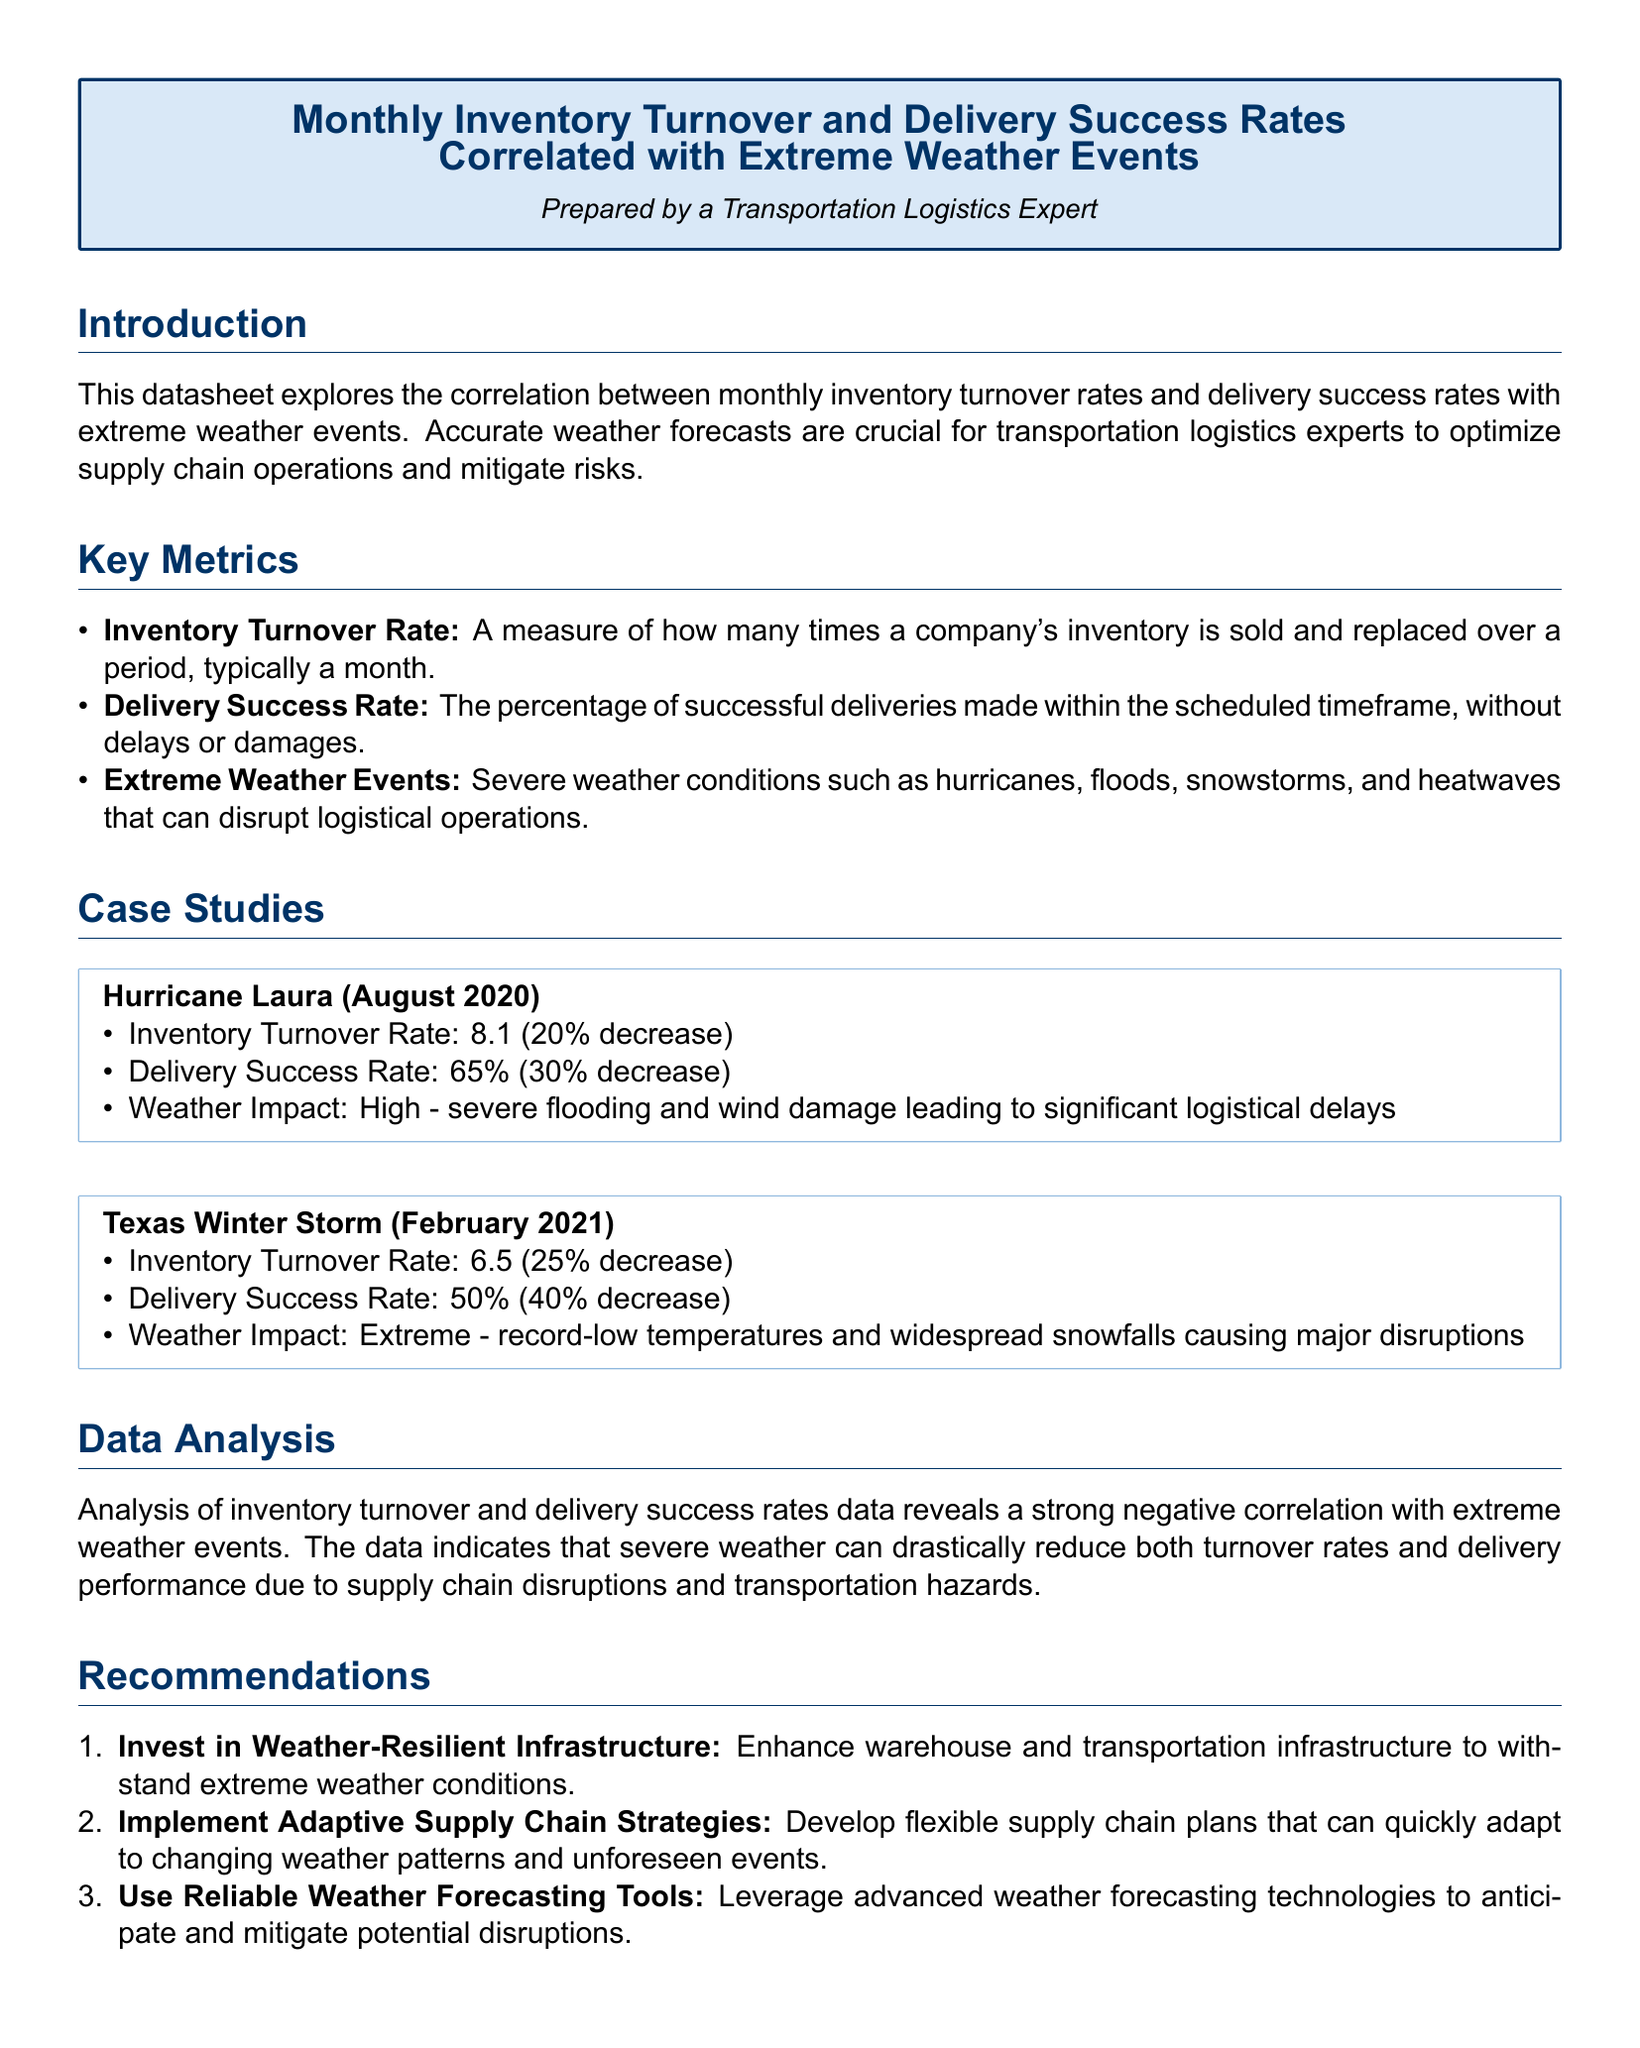What was the Inventory Turnover Rate during Hurricane Laura? The inventory turnover rate during Hurricane Laura was reported as 8.1, indicating a decrease.
Answer: 8.1 What was the Delivery Success Rate during the Texas Winter Storm? The delivery success rate during the Texas Winter Storm was noted as 50%, reflecting a significant decline.
Answer: 50% What were the weather impacts of Hurricane Laura? Hurricane Laura was classified with a high weather impact due to severe flooding and wind damage.
Answer: High What recommendation involves advancing technology? The datasheet recommends using reliable weather forecasting tools to anticipate disruptions.
Answer: Reliable weather forecasting tools By how much did the Delivery Success Rate decrease during Hurricane Laura? The document states that the delivery success rate decreased by 30% during Hurricane Laura.
Answer: 30% What month did the Texas Winter Storm occur? The Texas Winter Storm occurred in February 2021, as specified in the case study.
Answer: February 2021 What is the impact of extreme weather events on inventory turnover rates? The analysis suggests a strong negative correlation between extreme weather events and inventory turnover rates.
Answer: Strong negative correlation What is the primary focus of the datasheet? The primary focus of the datasheet is the correlation between monthly inventory turnover and delivery success rates with extreme weather events.
Answer: Correlation What percentage decrease in Inventory Turnover Rate was observed during the Texas Winter Storm? The Inventory Turnover Rate during the Texas Winter Storm decreased by 25%.
Answer: 25% 